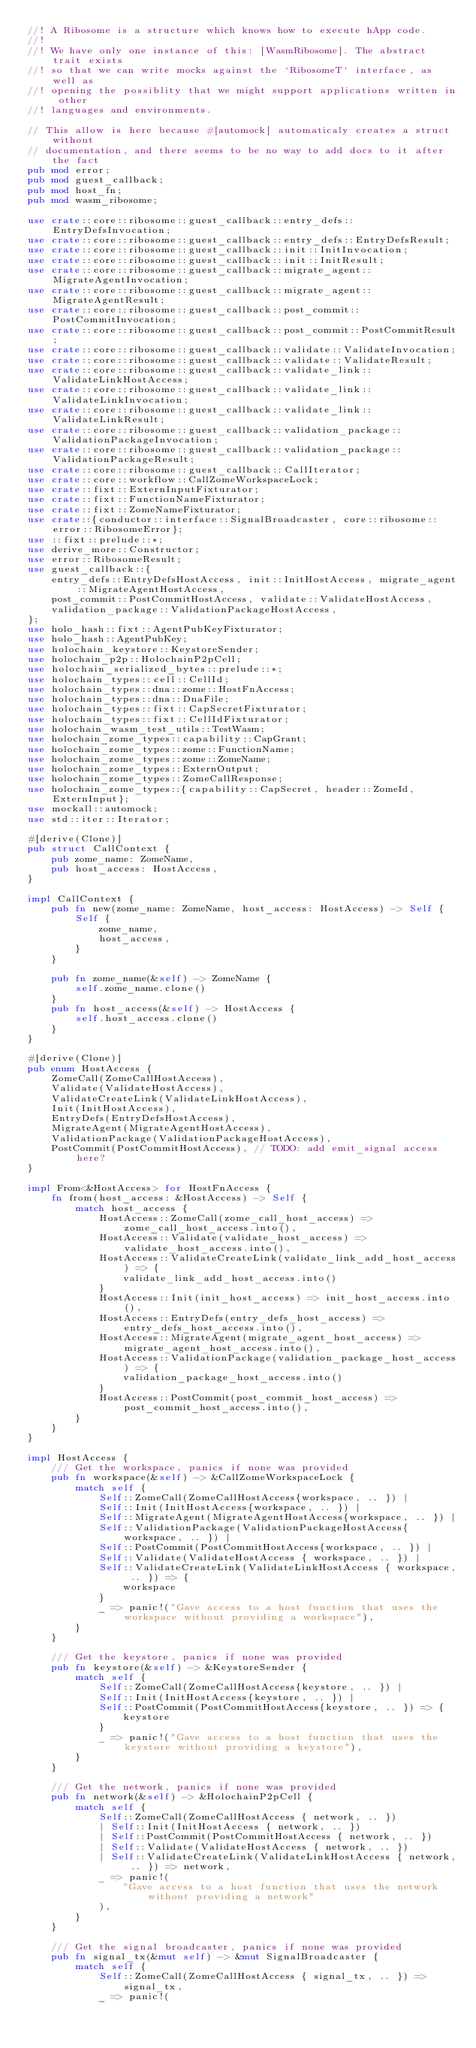<code> <loc_0><loc_0><loc_500><loc_500><_Rust_>//! A Ribosome is a structure which knows how to execute hApp code.
//!
//! We have only one instance of this: [WasmRibosome]. The abstract trait exists
//! so that we can write mocks against the `RibosomeT` interface, as well as
//! opening the possiblity that we might support applications written in other
//! languages and environments.

// This allow is here because #[automock] automaticaly creates a struct without
// documentation, and there seems to be no way to add docs to it after the fact
pub mod error;
pub mod guest_callback;
pub mod host_fn;
pub mod wasm_ribosome;

use crate::core::ribosome::guest_callback::entry_defs::EntryDefsInvocation;
use crate::core::ribosome::guest_callback::entry_defs::EntryDefsResult;
use crate::core::ribosome::guest_callback::init::InitInvocation;
use crate::core::ribosome::guest_callback::init::InitResult;
use crate::core::ribosome::guest_callback::migrate_agent::MigrateAgentInvocation;
use crate::core::ribosome::guest_callback::migrate_agent::MigrateAgentResult;
use crate::core::ribosome::guest_callback::post_commit::PostCommitInvocation;
use crate::core::ribosome::guest_callback::post_commit::PostCommitResult;
use crate::core::ribosome::guest_callback::validate::ValidateInvocation;
use crate::core::ribosome::guest_callback::validate::ValidateResult;
use crate::core::ribosome::guest_callback::validate_link::ValidateLinkHostAccess;
use crate::core::ribosome::guest_callback::validate_link::ValidateLinkInvocation;
use crate::core::ribosome::guest_callback::validate_link::ValidateLinkResult;
use crate::core::ribosome::guest_callback::validation_package::ValidationPackageInvocation;
use crate::core::ribosome::guest_callback::validation_package::ValidationPackageResult;
use crate::core::ribosome::guest_callback::CallIterator;
use crate::core::workflow::CallZomeWorkspaceLock;
use crate::fixt::ExternInputFixturator;
use crate::fixt::FunctionNameFixturator;
use crate::fixt::ZomeNameFixturator;
use crate::{conductor::interface::SignalBroadcaster, core::ribosome::error::RibosomeError};
use ::fixt::prelude::*;
use derive_more::Constructor;
use error::RibosomeResult;
use guest_callback::{
    entry_defs::EntryDefsHostAccess, init::InitHostAccess, migrate_agent::MigrateAgentHostAccess,
    post_commit::PostCommitHostAccess, validate::ValidateHostAccess,
    validation_package::ValidationPackageHostAccess,
};
use holo_hash::fixt::AgentPubKeyFixturator;
use holo_hash::AgentPubKey;
use holochain_keystore::KeystoreSender;
use holochain_p2p::HolochainP2pCell;
use holochain_serialized_bytes::prelude::*;
use holochain_types::cell::CellId;
use holochain_types::dna::zome::HostFnAccess;
use holochain_types::dna::DnaFile;
use holochain_types::fixt::CapSecretFixturator;
use holochain_types::fixt::CellIdFixturator;
use holochain_wasm_test_utils::TestWasm;
use holochain_zome_types::capability::CapGrant;
use holochain_zome_types::zome::FunctionName;
use holochain_zome_types::zome::ZomeName;
use holochain_zome_types::ExternOutput;
use holochain_zome_types::ZomeCallResponse;
use holochain_zome_types::{capability::CapSecret, header::ZomeId, ExternInput};
use mockall::automock;
use std::iter::Iterator;

#[derive(Clone)]
pub struct CallContext {
    pub zome_name: ZomeName,
    pub host_access: HostAccess,
}

impl CallContext {
    pub fn new(zome_name: ZomeName, host_access: HostAccess) -> Self {
        Self {
            zome_name,
            host_access,
        }
    }

    pub fn zome_name(&self) -> ZomeName {
        self.zome_name.clone()
    }
    pub fn host_access(&self) -> HostAccess {
        self.host_access.clone()
    }
}

#[derive(Clone)]
pub enum HostAccess {
    ZomeCall(ZomeCallHostAccess),
    Validate(ValidateHostAccess),
    ValidateCreateLink(ValidateLinkHostAccess),
    Init(InitHostAccess),
    EntryDefs(EntryDefsHostAccess),
    MigrateAgent(MigrateAgentHostAccess),
    ValidationPackage(ValidationPackageHostAccess),
    PostCommit(PostCommitHostAccess), // TODO: add emit_signal access here?
}

impl From<&HostAccess> for HostFnAccess {
    fn from(host_access: &HostAccess) -> Self {
        match host_access {
            HostAccess::ZomeCall(zome_call_host_access) => zome_call_host_access.into(),
            HostAccess::Validate(validate_host_access) => validate_host_access.into(),
            HostAccess::ValidateCreateLink(validate_link_add_host_access) => {
                validate_link_add_host_access.into()
            }
            HostAccess::Init(init_host_access) => init_host_access.into(),
            HostAccess::EntryDefs(entry_defs_host_access) => entry_defs_host_access.into(),
            HostAccess::MigrateAgent(migrate_agent_host_access) => migrate_agent_host_access.into(),
            HostAccess::ValidationPackage(validation_package_host_access) => {
                validation_package_host_access.into()
            }
            HostAccess::PostCommit(post_commit_host_access) => post_commit_host_access.into(),
        }
    }
}

impl HostAccess {
    /// Get the workspace, panics if none was provided
    pub fn workspace(&self) -> &CallZomeWorkspaceLock {
        match self {
            Self::ZomeCall(ZomeCallHostAccess{workspace, .. }) |
            Self::Init(InitHostAccess{workspace, .. }) |
            Self::MigrateAgent(MigrateAgentHostAccess{workspace, .. }) |
            Self::ValidationPackage(ValidationPackageHostAccess{workspace, .. }) |
            Self::PostCommit(PostCommitHostAccess{workspace, .. }) |
            Self::Validate(ValidateHostAccess { workspace, .. }) |
            Self::ValidateCreateLink(ValidateLinkHostAccess { workspace, .. }) => {
                workspace
            }
            _ => panic!("Gave access to a host function that uses the workspace without providing a workspace"),
        }
    }

    /// Get the keystore, panics if none was provided
    pub fn keystore(&self) -> &KeystoreSender {
        match self {
            Self::ZomeCall(ZomeCallHostAccess{keystore, .. }) |
            Self::Init(InitHostAccess{keystore, .. }) |
            Self::PostCommit(PostCommitHostAccess{keystore, .. }) => {
                keystore
            }
            _ => panic!("Gave access to a host function that uses the keystore without providing a keystore"),
        }
    }

    /// Get the network, panics if none was provided
    pub fn network(&self) -> &HolochainP2pCell {
        match self {
            Self::ZomeCall(ZomeCallHostAccess { network, .. })
            | Self::Init(InitHostAccess { network, .. })
            | Self::PostCommit(PostCommitHostAccess { network, .. })
            | Self::Validate(ValidateHostAccess { network, .. })
            | Self::ValidateCreateLink(ValidateLinkHostAccess { network, .. }) => network,
            _ => panic!(
                "Gave access to a host function that uses the network without providing a network"
            ),
        }
    }

    /// Get the signal broadcaster, panics if none was provided
    pub fn signal_tx(&mut self) -> &mut SignalBroadcaster {
        match self {
            Self::ZomeCall(ZomeCallHostAccess { signal_tx, .. }) => signal_tx,
            _ => panic!(</code> 